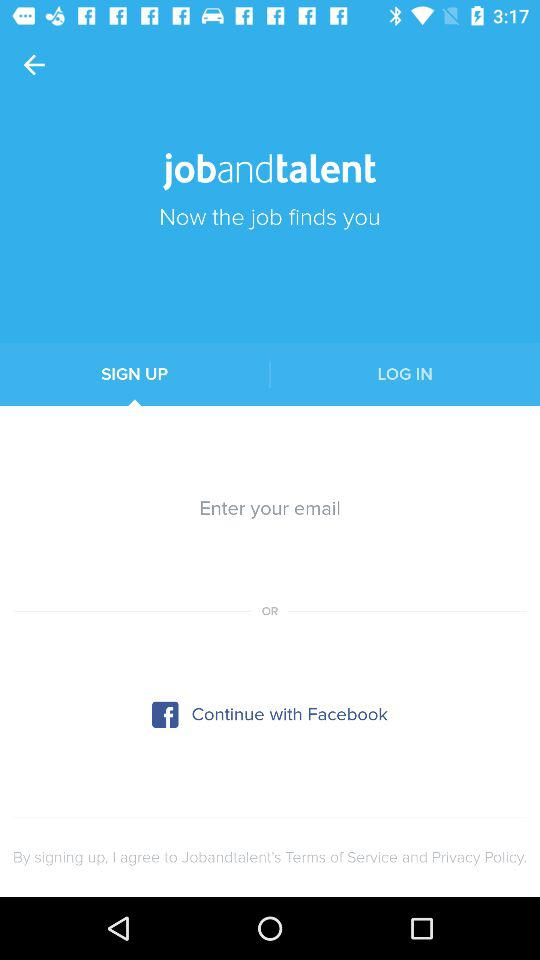How many options are there to sign up?
Answer the question using a single word or phrase. 2 